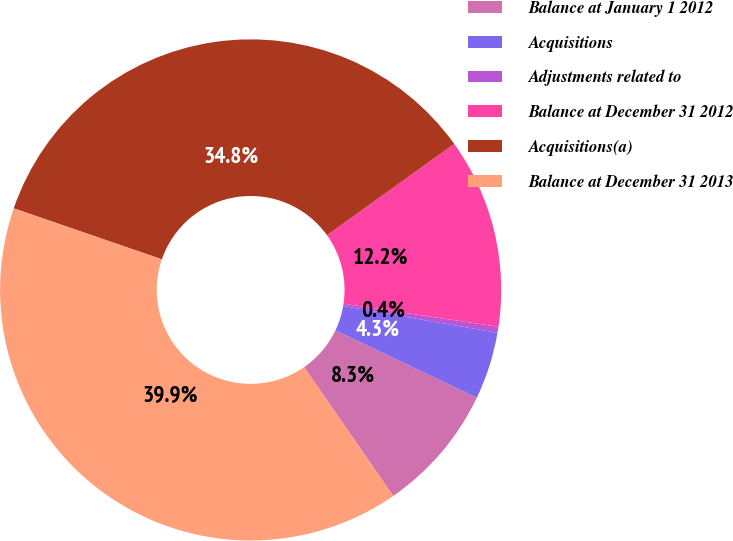Convert chart to OTSL. <chart><loc_0><loc_0><loc_500><loc_500><pie_chart><fcel>Balance at January 1 2012<fcel>Acquisitions<fcel>Adjustments related to<fcel>Balance at December 31 2012<fcel>Acquisitions(a)<fcel>Balance at December 31 2013<nl><fcel>8.29%<fcel>4.34%<fcel>0.39%<fcel>12.25%<fcel>34.82%<fcel>39.91%<nl></chart> 